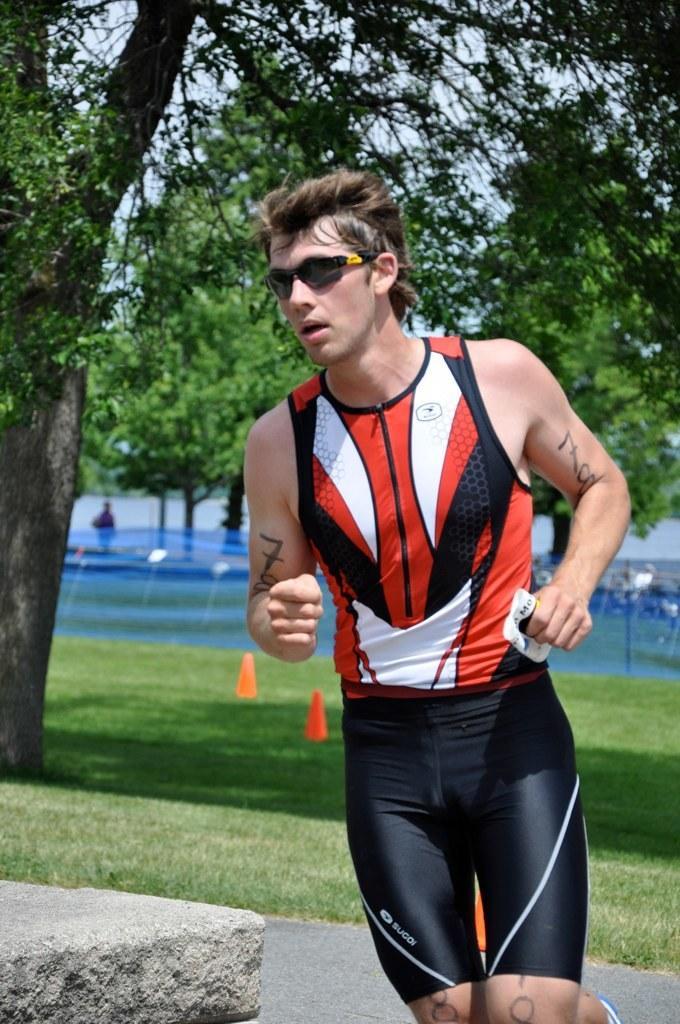Could you give a brief overview of what you see in this image? In this picture there is a man in the center of the image, it seems to be he is running and there are trees, grassland and water in the background area of the image. 